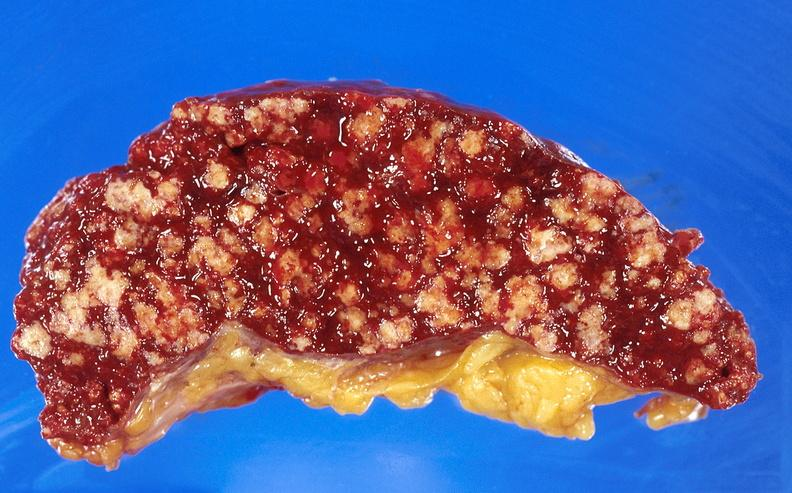where is this part in?
Answer the question using a single word or phrase. Spleen 